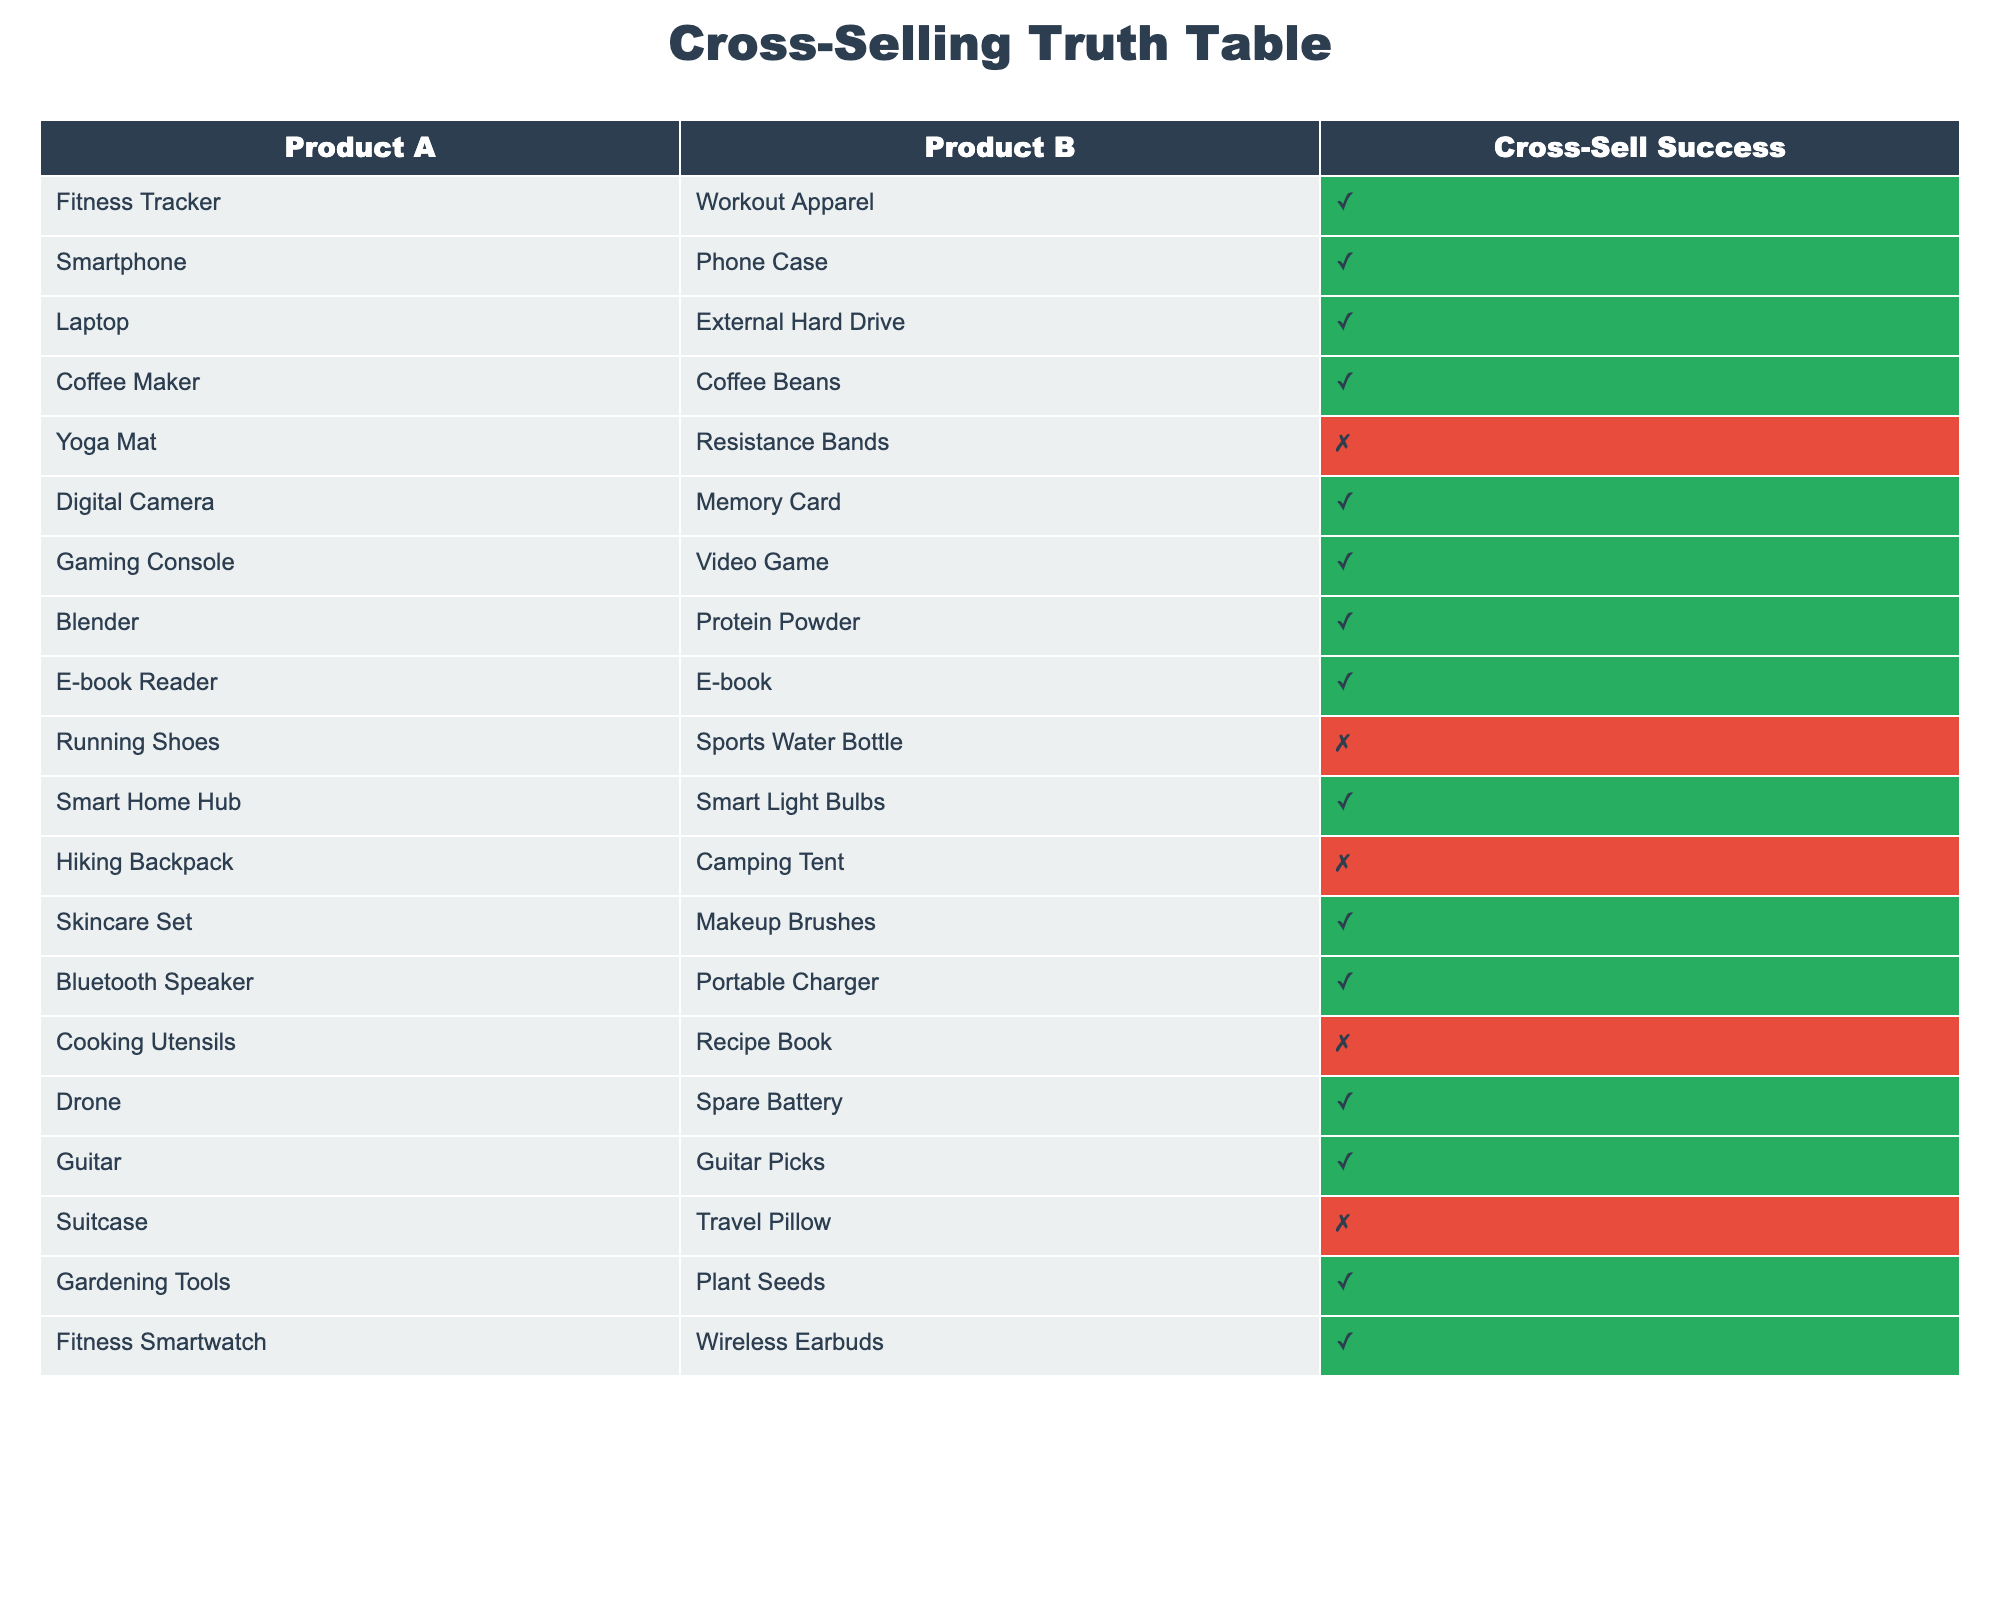What products have cross-sell success? The table lists pairs of products and their cross-sell success status (TRUE or FALSE). By looking at the "Cross-Sell Success" column for products where the value is TRUE, the products are: Fitness Tracker & Workout Apparel, Smartphone & Phone Case, Laptop & External Hard Drive, Coffee Maker & Coffee Beans, Digital Camera & Memory Card, Gaming Console & Video Game, Blender & Protein Powder, E-book Reader & E-book, Smart Home Hub & Smart Light Bulbs, Skincare Set & Makeup Brushes, Bluetooth Speaker & Portable Charger, Drone & Spare Battery, Guitar & Guitar Picks, Gardening Tools & Plant Seeds, Fitness Smartwatch & Wireless Earbuds.
Answer: Fitness Tracker, Smartphone, Laptop, Coffee Maker, Digital Camera, Gaming Console, Blender, E-book Reader, Smart Home Hub, Skincare Set, Bluetooth Speaker, Drone, Guitar, Gardening Tools, Fitness Smartwatch Which pairs have not succeeded in cross-selling? The table shows which pairs were unsuccessful by looking for FALSE values in the "Cross-Sell Success" column. The product pairs that correspond to FALSE are: Yoga Mat & Resistance Bands, Running Shoes & Sports Water Bottle, Hiking Backpack & Camping Tent, Cooking Utensils & Recipe Book, and Suitcase & Travel Pillow.
Answer: Yoga Mat & Resistance Bands, Running Shoes & Sports Water Bottle, Hiking Backpack & Camping Tent, Cooking Utensils & Recipe Book, Suitcase & Travel Pillow How many successful cross-sell pairs are there? To find the count of successful cross-sell pairs, we count the number of TRUE values in the "Cross-Sell Success" column. By checking the table, there are 15 TRUE entries.
Answer: 15 How many total product pairs were analyzed? The total number of product pairs can be determined by counting the rows in the table. There are 20 rows in total, indicating 20 product pairs were analyzed.
Answer: 20 Is there a relationship between fitness-related products and cross-sell success? We examine the fitness-related products: Fitness Tracker & Workout Apparel and Blender & Protein Powder, alongside Fitness Smartwatch & Wireless Earbuds to evaluate their success. All three pairs have TRUE in the "Cross-Sell Success" column, suggesting a positive relationship between fitness-related products and successful cross-selling.
Answer: Yes Which complementary niches have the highest success rate? This requires checking the number of successful pairs per niche; the fitness-related products (3 out of 3) have a 100% success rate, while other niches vary. The niches like Skincare and Smart Home also demonstrate high success rates but not 100%. Thus, fitness-related products confirm the highest success rate.
Answer: Fitness niche 